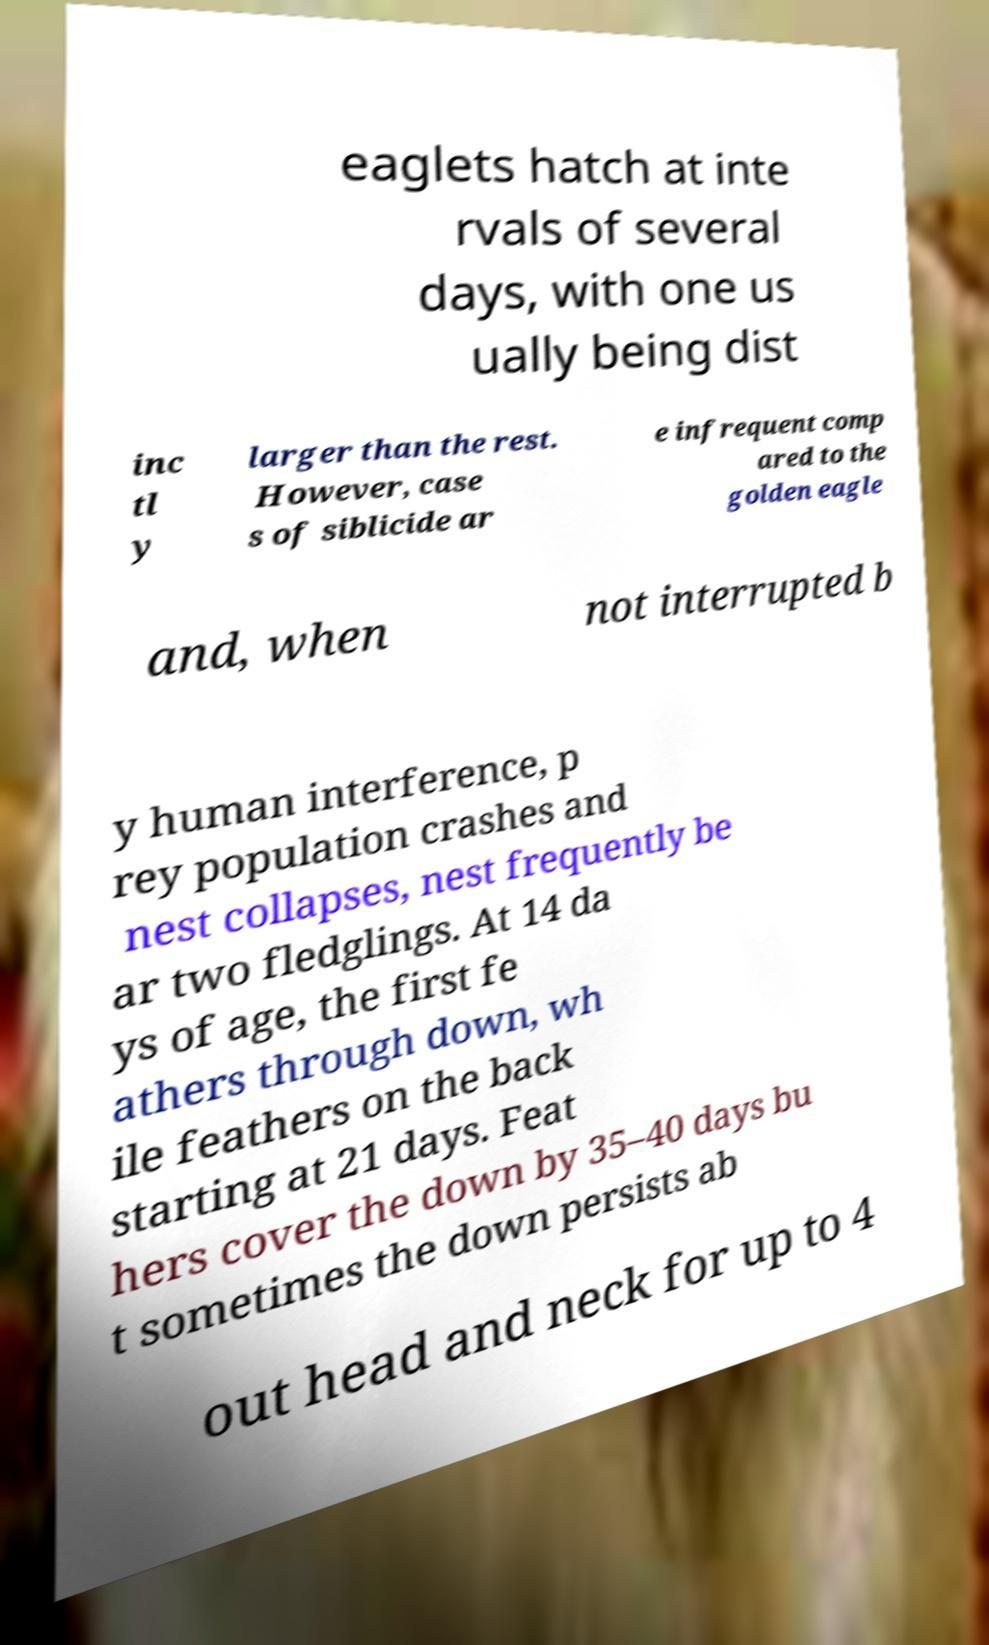I need the written content from this picture converted into text. Can you do that? eaglets hatch at inte rvals of several days, with one us ually being dist inc tl y larger than the rest. However, case s of siblicide ar e infrequent comp ared to the golden eagle and, when not interrupted b y human interference, p rey population crashes and nest collapses, nest frequently be ar two fledglings. At 14 da ys of age, the first fe athers through down, wh ile feathers on the back starting at 21 days. Feat hers cover the down by 35–40 days bu t sometimes the down persists ab out head and neck for up to 4 